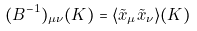Convert formula to latex. <formula><loc_0><loc_0><loc_500><loc_500>( B ^ { - 1 } ) _ { \mu \nu } ( K ) = \langle \tilde { x } _ { \mu } \tilde { x } _ { \nu } \rangle ( K )</formula> 